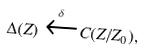<formula> <loc_0><loc_0><loc_500><loc_500>\Delta ( Z ) \xleftarrow { \delta } C ( Z / Z _ { 0 } ) ,</formula> 